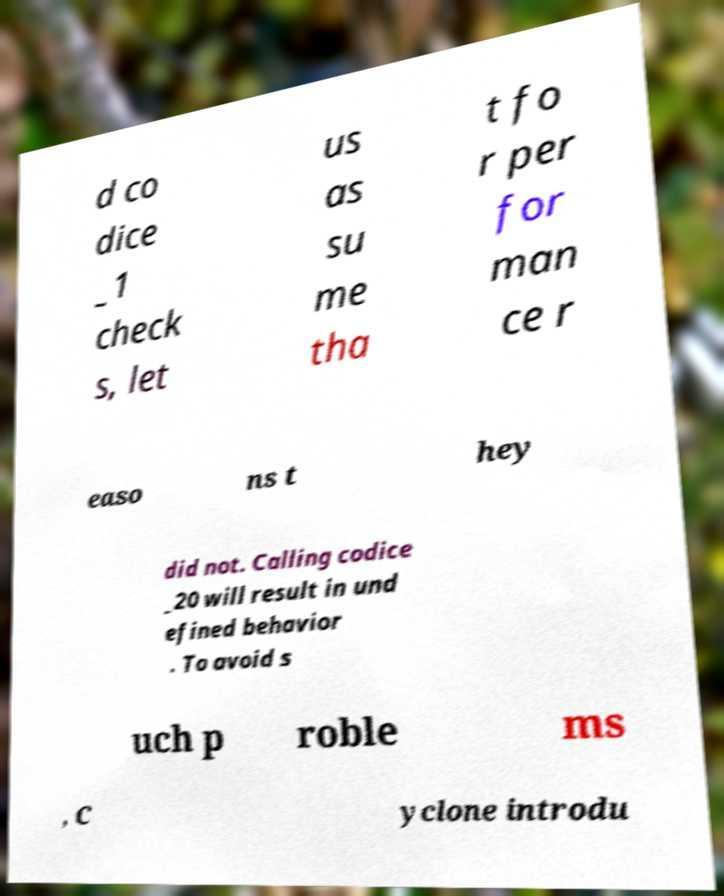There's text embedded in this image that I need extracted. Can you transcribe it verbatim? d co dice _1 check s, let us as su me tha t fo r per for man ce r easo ns t hey did not. Calling codice _20 will result in und efined behavior . To avoid s uch p roble ms , C yclone introdu 